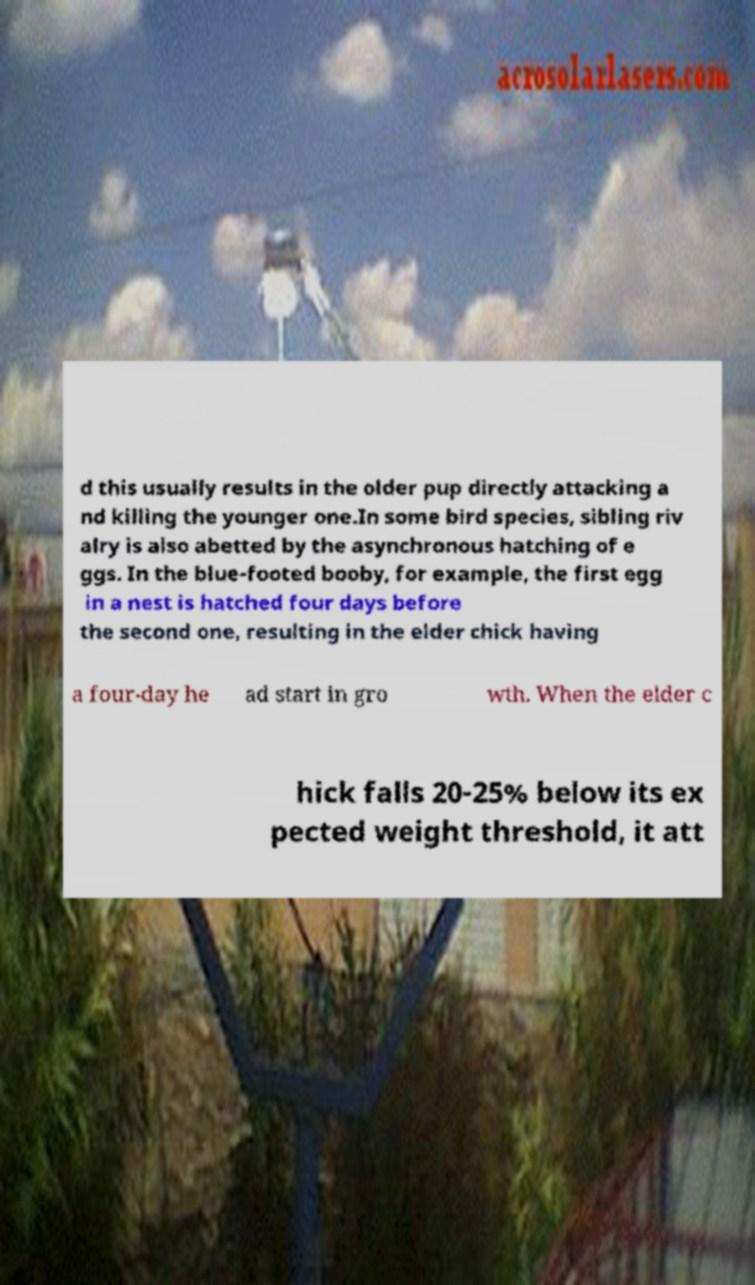For documentation purposes, I need the text within this image transcribed. Could you provide that? d this usually results in the older pup directly attacking a nd killing the younger one.In some bird species, sibling riv alry is also abetted by the asynchronous hatching of e ggs. In the blue-footed booby, for example, the first egg in a nest is hatched four days before the second one, resulting in the elder chick having a four-day he ad start in gro wth. When the elder c hick falls 20-25% below its ex pected weight threshold, it att 